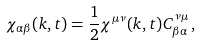Convert formula to latex. <formula><loc_0><loc_0><loc_500><loc_500>\chi _ { \alpha \beta } ( { k } , t ) = \frac { 1 } { 2 } \chi ^ { \mu \nu } ( { k } , t ) C ^ { \nu \mu } _ { \beta \alpha } \, ,</formula> 